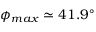<formula> <loc_0><loc_0><loc_500><loc_500>\phi _ { \max } \simeq 4 1 . 9 ^ { \circ }</formula> 